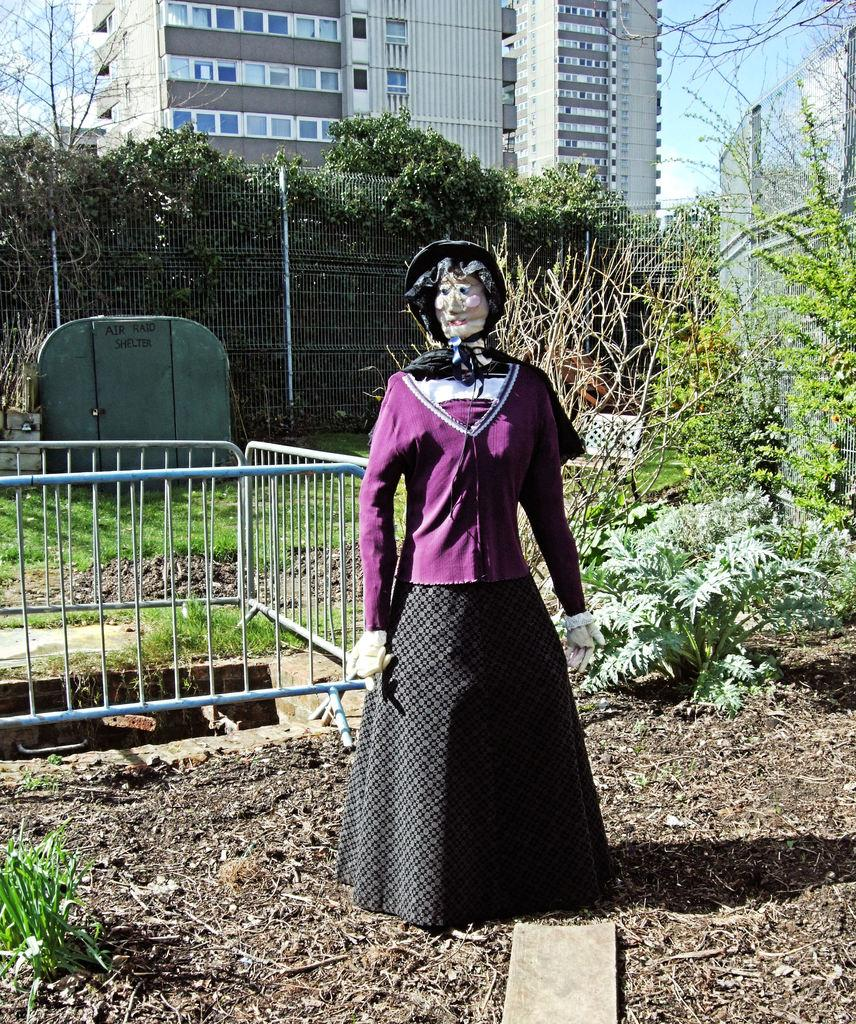What type of toy is placed on the ground in the image? There is a scary toy placed on the ground in the image. What can be seen behind the toy? There are objects behind the toy. What type of barrier is visible in the image? There is fencing visible in the image. What type of natural elements can be seen in the background? There are plants, trees, and buildings in the background. What type of toothpaste is being used by the men in the image? There are no men or toothpaste present in the image. What type of feather can be seen on the scary toy in the image? There is no feather present on the scary toy in the image. 